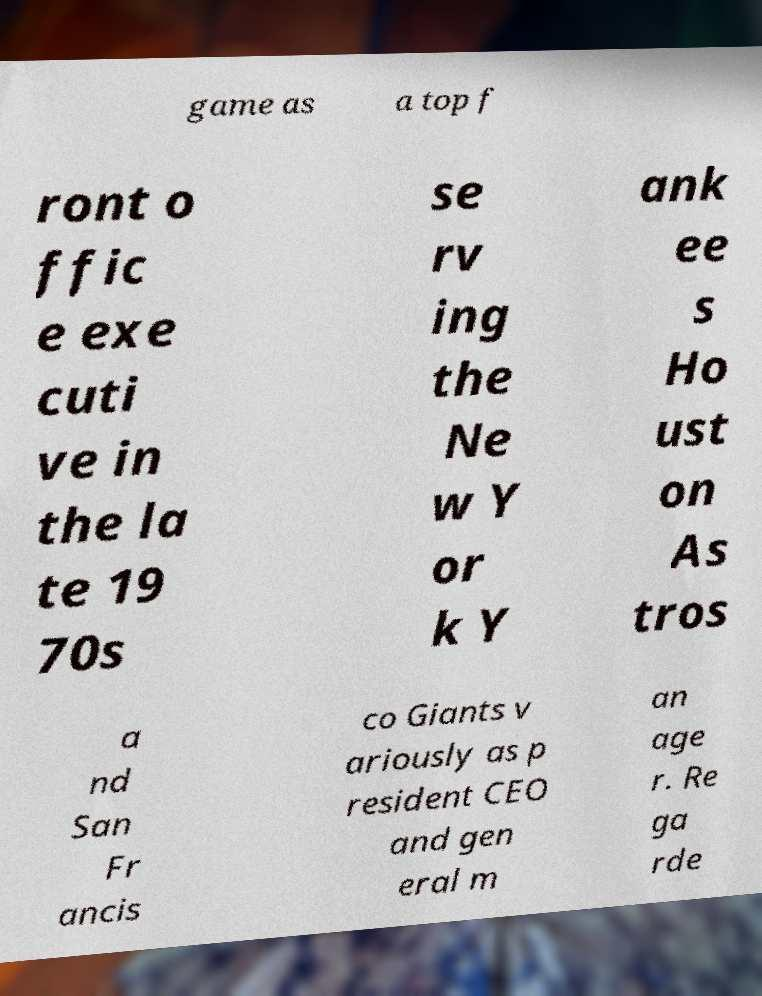Can you accurately transcribe the text from the provided image for me? game as a top f ront o ffic e exe cuti ve in the la te 19 70s se rv ing the Ne w Y or k Y ank ee s Ho ust on As tros a nd San Fr ancis co Giants v ariously as p resident CEO and gen eral m an age r. Re ga rde 